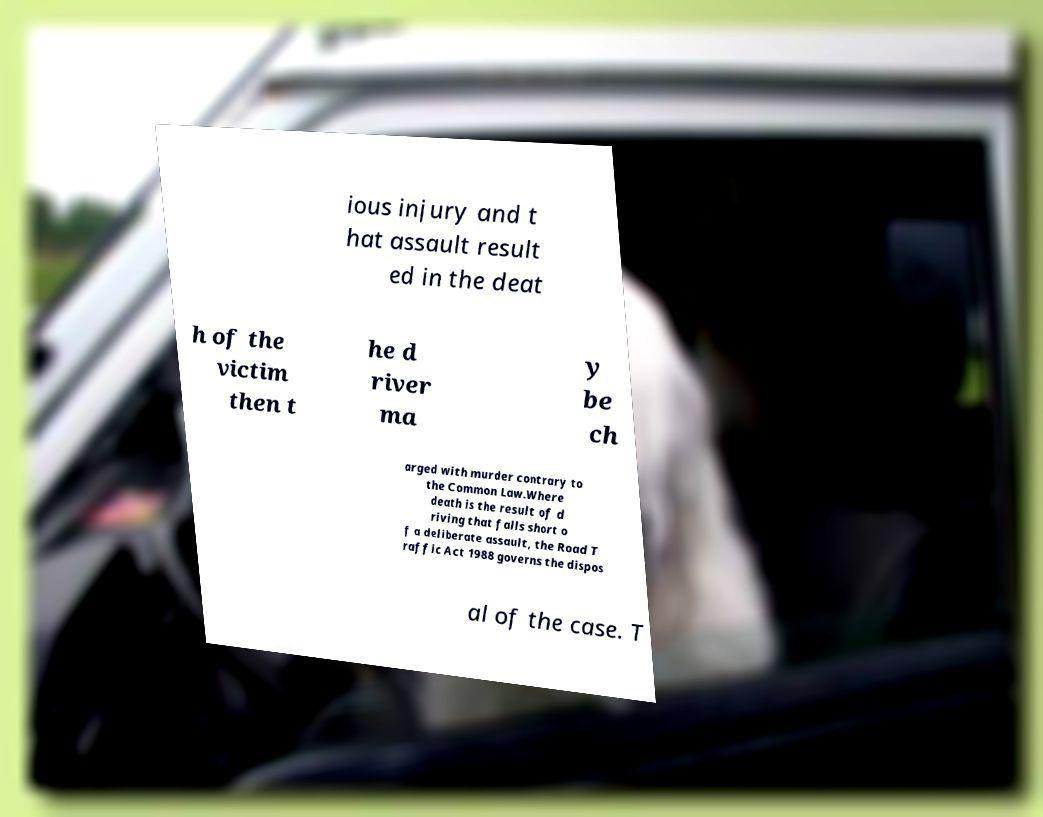Can you read and provide the text displayed in the image?This photo seems to have some interesting text. Can you extract and type it out for me? ious injury and t hat assault result ed in the deat h of the victim then t he d river ma y be ch arged with murder contrary to the Common Law.Where death is the result of d riving that falls short o f a deliberate assault, the Road T raffic Act 1988 governs the dispos al of the case. T 